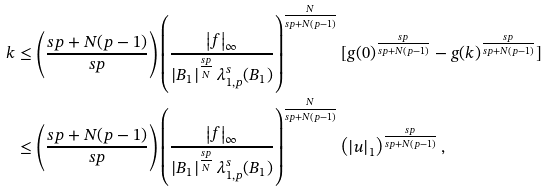Convert formula to latex. <formula><loc_0><loc_0><loc_500><loc_500>k & \leq \left ( \frac { s p + N ( p - 1 ) } { s p } \right ) \left ( \frac { \left | f \right | _ { \infty } } { \left | B _ { 1 } \right | ^ { \frac { s p } { N } } \lambda _ { 1 , p } ^ { s } ( B _ { 1 } ) } \right ) ^ { \frac { N } { s p + N ( p - 1 ) } } [ g ( 0 ) ^ { \frac { s p } { s p + N ( p - 1 ) } } - g ( k ) ^ { \frac { s p } { s p + N ( p - 1 ) } } ] \\ & \leq \left ( \frac { s p + N ( p - 1 ) } { s p } \right ) \left ( \frac { \left | f \right | _ { \infty } } { \left | B _ { 1 } \right | ^ { \frac { s p } { N } } \lambda _ { 1 , p } ^ { s } ( B _ { 1 } ) } \right ) ^ { \frac { N } { s p + N ( p - 1 ) } } \left ( \left | u \right | _ { 1 } \right ) ^ { \frac { s p } { s p + N ( p - 1 ) } } ,</formula> 